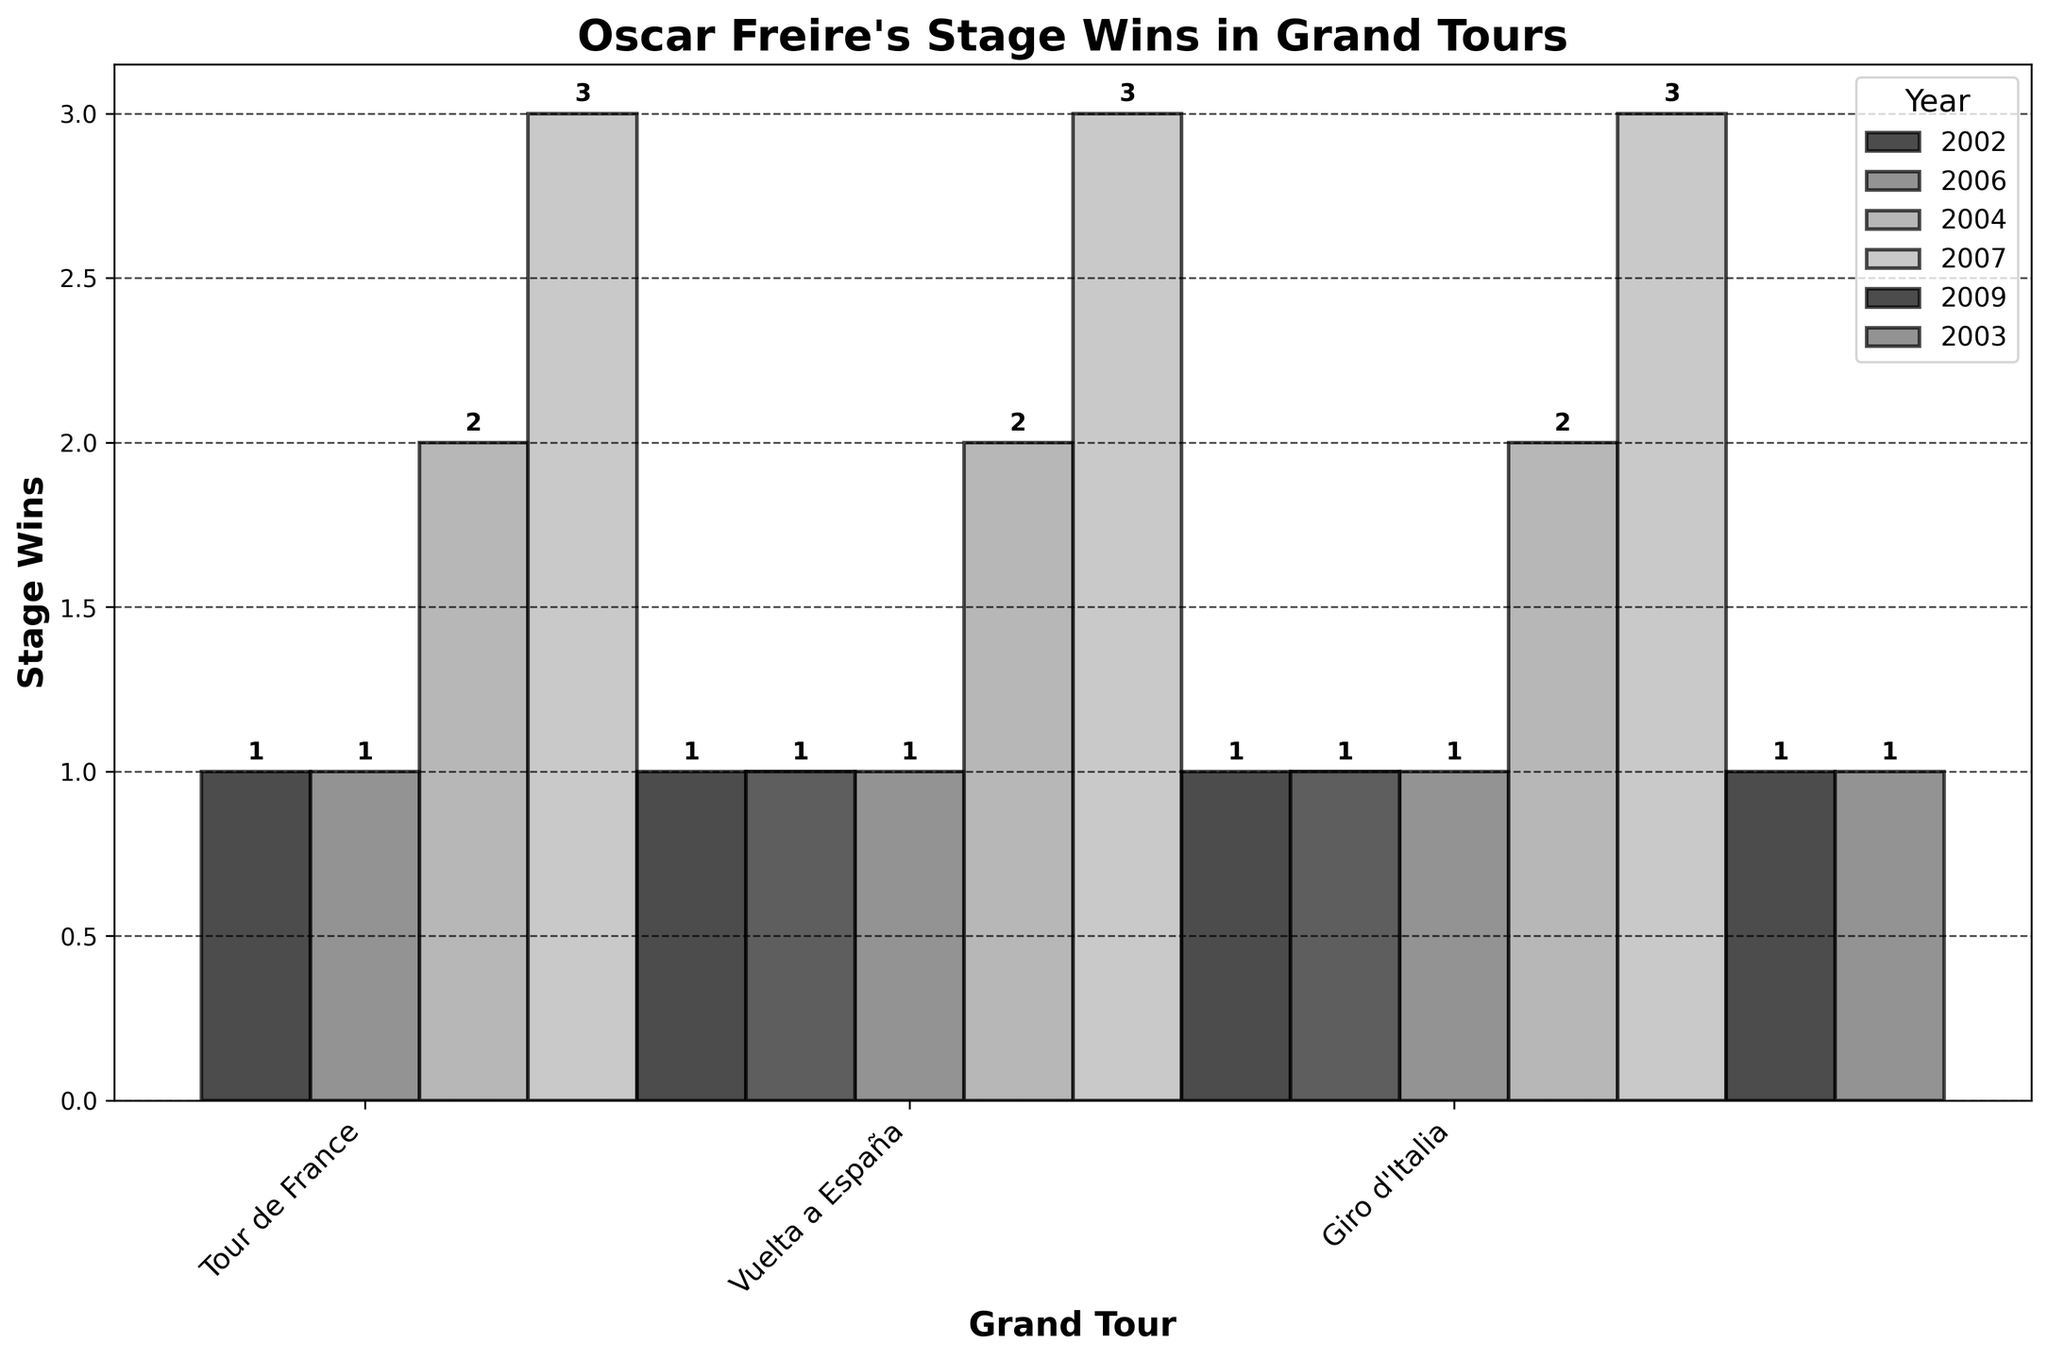How many stage wins did Oscar Freire achieve in the Vuelta a España in 2007? Locate the bar for the Vuelta a España in 2007. The y-axis value for this bar indicates the stage wins.
Answer: 3 In which year did Oscar Freire have the most stage wins, and in which race? Compare the height of the bars across different years. The tallest bar represents the highest number of stage wins. Look for the year and corresponding race.
Answer: 2007, Vuelta a España How many total stage wins did Oscar Freire achieve in the Tour de France? Sum the stage wins from all the bars representing the Tour de France. Add the values for 2002 and 2006.
Answer: 2 Which year had the second-highest number of stage wins for Oscar Freire, and in which race? Identify the year and race with the second highest bar after the one in 2007. Compare other bars across all races and years.
Answer: 2004, Vuelta a España 